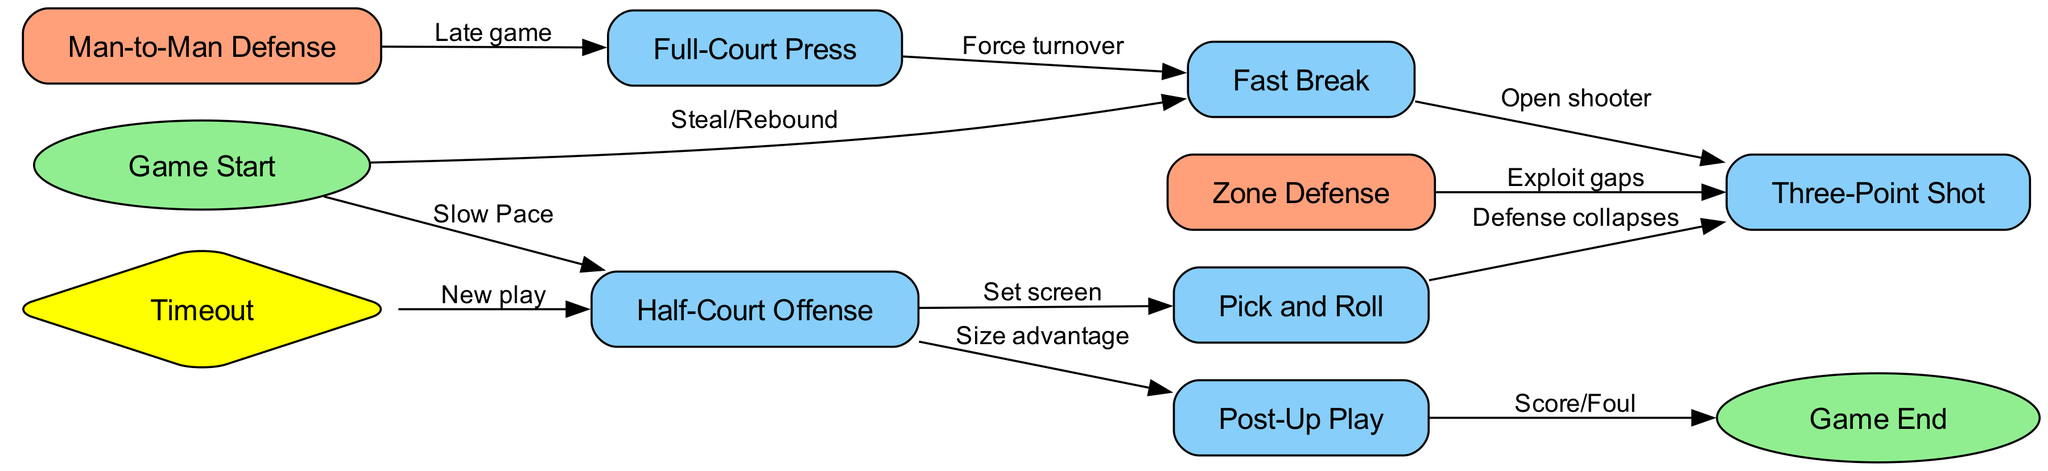What is the starting point of the flowchart? The flowchart begins at the "Game Start" node, which is the entry point for all strategies and plays.
Answer: Game Start How many nodes are in the diagram? To find the total number of nodes, list all unique nodes described in the data. The nodes provided are: Game Start, Fast Break, Half-Court Offense, Pick and Roll, Zone Defense, Man-to-Man Defense, Full-Court Press, Three-Point Shot, Post-Up Play, Timeout, and Game End, totaling 11 nodes.
Answer: 11 What action leads to a Three-Point Shot from Fast Break? From the Fast Break node, the edge labeled "Open shooter" leads directly to the Three-Point Shot node, indicating that this is the action required to take that shot.
Answer: Open shooter What strategy follows a Timeout according to the diagram? The diagram indicates that from the "Timeout" node, the next strategy executed is "Half-Court Offense". This connection shows a specific plan initiated after a timeout.
Answer: Half-Court Offense Which defense strategy is executed during the late game? The edge originating from "Man-to-Man Defense" leads to "Full-Court Press". This sequence indicates that the Full-Court Press strategy is employed in late-game scenarios when using Man-to-Man Defense.
Answer: Full-Court Press How can a team exploit gaps in the defense? According to the diagram, the flow leads from "Zone Defense" to "Three-Point Shot", which suggests that teams can take advantage of gaps in a Zone Defense to create opportunities for three-point attempts.
Answer: Exploit gaps What is the final outcome if a team successfully executes a Post-Up Play? The edge from "Post-Up Play" points to "Game End" with the label "Score/Foul", indicating that the outcome of performing this play can lead directly to the conclusion of the game, depending on the result.
Answer: Score/Foul What leads from a Full-Court Press back to a Fast Break? The edge from "Full-Court Press" to "Fast Break" is labeled "Force turnover". This connection outlines a tactical reaction where forcing a turnover during a full-court press situation allows the team to transition quickly into a fast break.
Answer: Force turnover How many defensive strategies are represented in the diagram? The diagram contains three specific defense strategies identified as "Zone Defense", "Man-to-Man Defense", and "Full-Court Press", thus totaling three defensive strategies that can be employed.
Answer: 3 